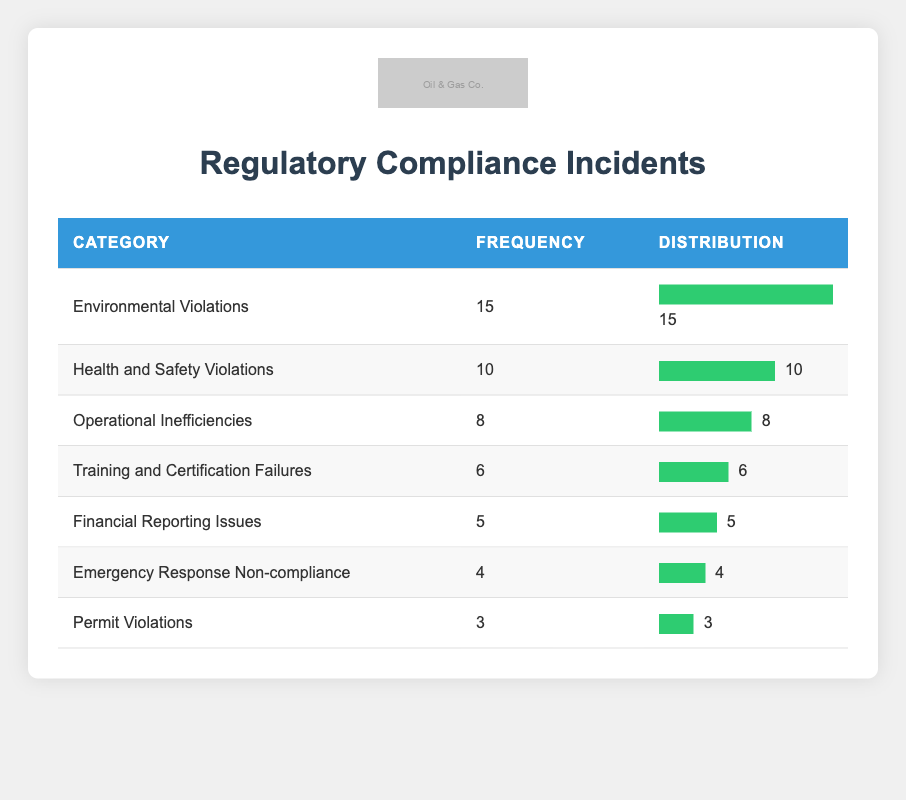What is the frequency of Environmental Violations? Environmental Violations has a listed frequency of 15 incidents in the table.
Answer: 15 How many categories have a frequency of 6 or more? The categories with frequency of 6 or more are: Environmental Violations (15), Health and Safety Violations (10), and Operational Inefficiencies (8), Training and Certification Failures (6). Counting these gives a total of 4 categories.
Answer: 4 Is the frequency of Emergency Response Non-compliance greater than Permit Violations? The frequency of Emergency Response Non-compliance is 4, while the frequency of Permit Violations is 3. Since 4 is greater than 3, the statement is true.
Answer: Yes What is the total frequency of all compliance incidents? The frequencies of all the categories are added as follows: 15 + 10 + 8 + 6 + 5 + 4 + 3 = 51. Thus, the total frequency of all incidents is 51.
Answer: 51 What is the difference in frequency between the highest and lowest category? The highest frequency is 15 (Environmental Violations) and the lowest frequency is 3 (Permit Violations). The difference is calculated as 15 - 3 = 12.
Answer: 12 What proportion of incidents are due to Financial Reporting Issues? The frequency of Financial Reporting Issues is 5. The total frequency of all incidents is 51. The proportion can be calculated as (5/51)*100 = approximately 9.8%.
Answer: 9.8% How many more incidents were reported for Environmental Violations compared to Training and Certification Failures? Environmental Violations reported 15 incidents while Training and Certification Failures reported 6. The difference is 15 - 6 = 9.
Answer: 9 Which category has the second highest frequency? The frequency values indicate that Health and Safety Violations have a frequency of 10, making it the second highest category after Environmental Violations with 15 incidents.
Answer: Health and Safety Violations 